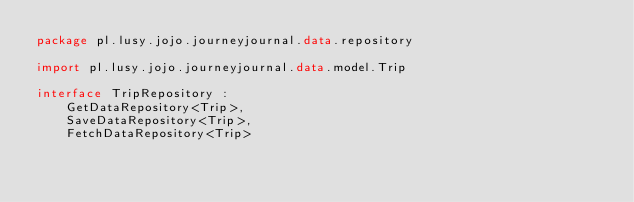<code> <loc_0><loc_0><loc_500><loc_500><_Kotlin_>package pl.lusy.jojo.journeyjournal.data.repository

import pl.lusy.jojo.journeyjournal.data.model.Trip

interface TripRepository :
    GetDataRepository<Trip>,
    SaveDataRepository<Trip>,
    FetchDataRepository<Trip>
</code> 